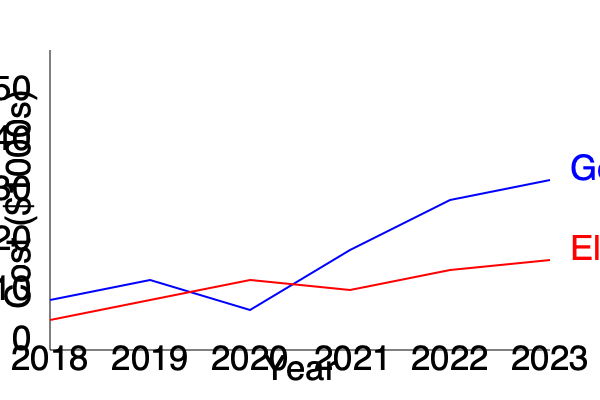As a property manager, you notice that the cost of general maintenance has increased more rapidly than elderly-specific maintenance over the past six years. Calculate the difference in the rate of increase between general maintenance and elderly-specific maintenance costs from 2018 to 2023. To solve this problem, we need to follow these steps:

1. Calculate the total increase in general maintenance costs from 2018 to 2023:
   2018 value: $10,000
   2023 value: $34,000
   Increase: $34,000 - $10,000 = $24,000

2. Calculate the total increase in elderly-specific maintenance costs from 2018 to 2023:
   2018 value: $6,000
   2023 value: $18,000
   Increase: $18,000 - $6,000 = $12,000

3. Calculate the rate of increase for general maintenance:
   Rate = (Increase / Initial Value) × 100
   Rate = ($24,000 / $10,000) × 100 = 240%

4. Calculate the rate of increase for elderly-specific maintenance:
   Rate = ($12,000 / $6,000) × 100 = 200%

5. Calculate the difference in the rates of increase:
   Difference = General Maintenance Rate - Elderly-Specific Maintenance Rate
   Difference = 240% - 200% = 40%

Therefore, the difference in the rate of increase between general maintenance and elderly-specific maintenance costs from 2018 to 2023 is 40 percentage points.
Answer: 40 percentage points 